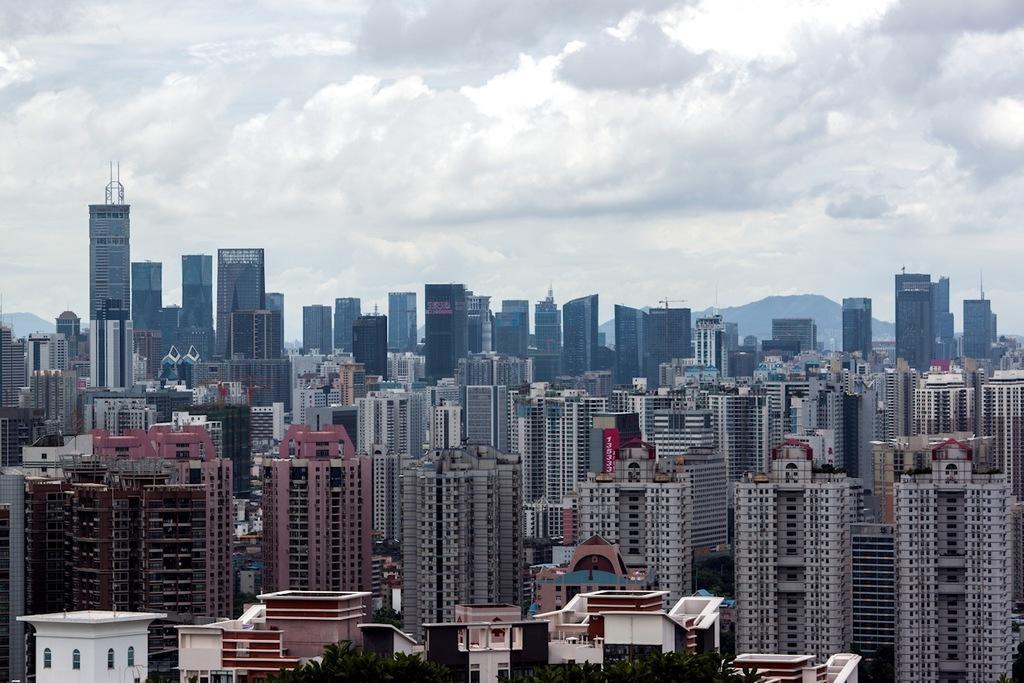Can you describe this image briefly? In the image there are many buildings. At the bottom of the image there are trees. Behind the buildings there are hills. At the top of the image there is sky with clouds. 